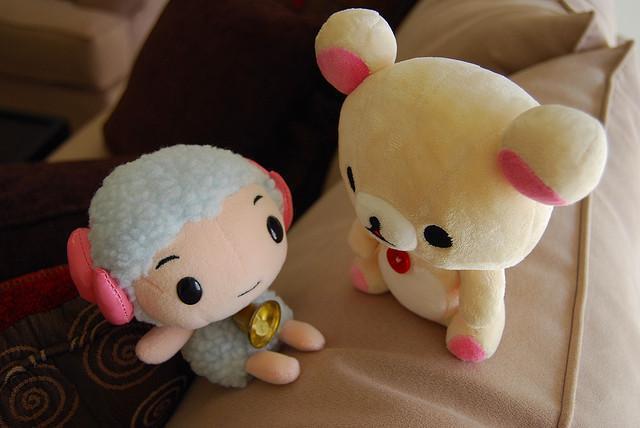How many bears?
Give a very brief answer. 1. How many teddy bears are visible?
Give a very brief answer. 1. How many people are wearing helmet?
Give a very brief answer. 0. 